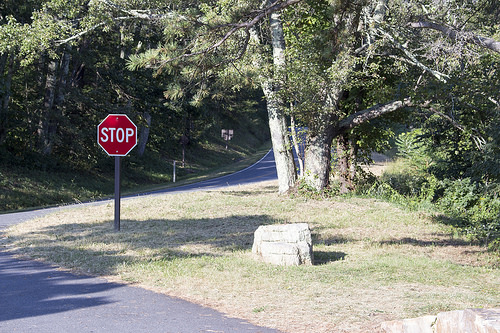<image>
Is the stop sign in the road? No. The stop sign is not contained within the road. These objects have a different spatial relationship. 